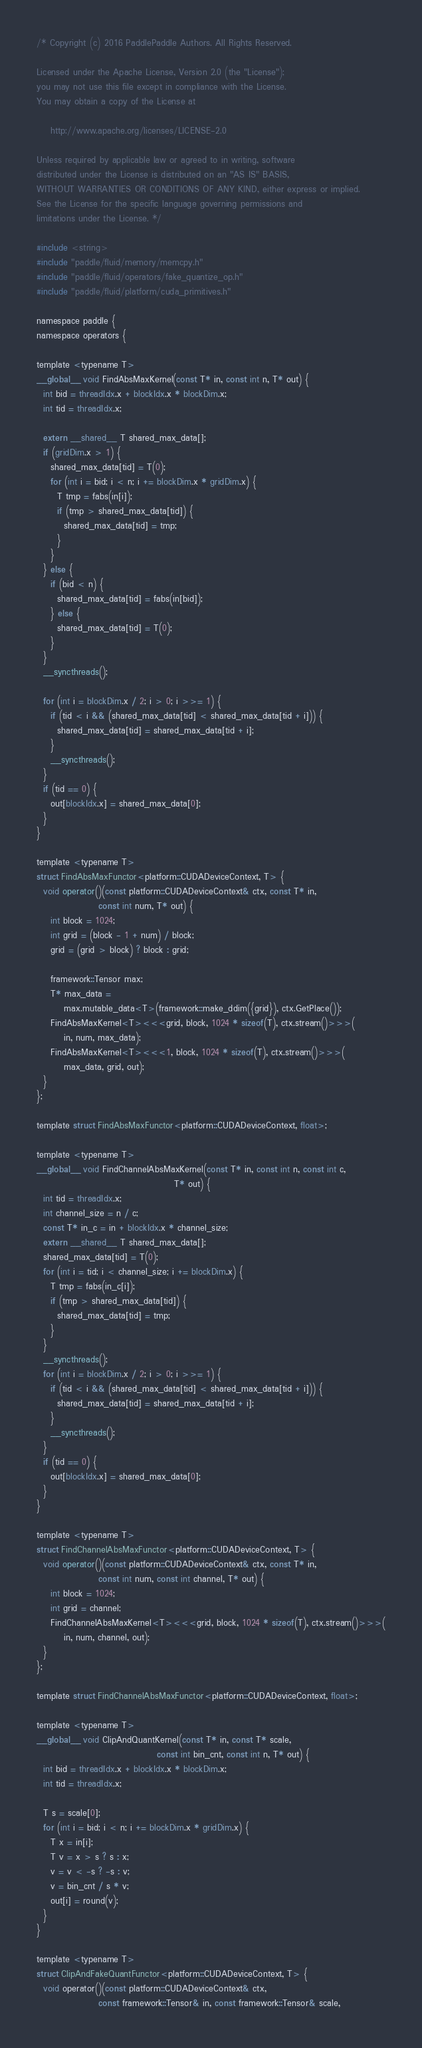<code> <loc_0><loc_0><loc_500><loc_500><_Cuda_>/* Copyright (c) 2016 PaddlePaddle Authors. All Rights Reserved.

Licensed under the Apache License, Version 2.0 (the "License");
you may not use this file except in compliance with the License.
You may obtain a copy of the License at

    http://www.apache.org/licenses/LICENSE-2.0

Unless required by applicable law or agreed to in writing, software
distributed under the License is distributed on an "AS IS" BASIS,
WITHOUT WARRANTIES OR CONDITIONS OF ANY KIND, either express or implied.
See the License for the specific language governing permissions and
limitations under the License. */

#include <string>
#include "paddle/fluid/memory/memcpy.h"
#include "paddle/fluid/operators/fake_quantize_op.h"
#include "paddle/fluid/platform/cuda_primitives.h"

namespace paddle {
namespace operators {

template <typename T>
__global__ void FindAbsMaxKernel(const T* in, const int n, T* out) {
  int bid = threadIdx.x + blockIdx.x * blockDim.x;
  int tid = threadIdx.x;

  extern __shared__ T shared_max_data[];
  if (gridDim.x > 1) {
    shared_max_data[tid] = T(0);
    for (int i = bid; i < n; i += blockDim.x * gridDim.x) {
      T tmp = fabs(in[i]);
      if (tmp > shared_max_data[tid]) {
        shared_max_data[tid] = tmp;
      }
    }
  } else {
    if (bid < n) {
      shared_max_data[tid] = fabs(in[bid]);
    } else {
      shared_max_data[tid] = T(0);
    }
  }
  __syncthreads();

  for (int i = blockDim.x / 2; i > 0; i >>= 1) {
    if (tid < i && (shared_max_data[tid] < shared_max_data[tid + i])) {
      shared_max_data[tid] = shared_max_data[tid + i];
    }
    __syncthreads();
  }
  if (tid == 0) {
    out[blockIdx.x] = shared_max_data[0];
  }
}

template <typename T>
struct FindAbsMaxFunctor<platform::CUDADeviceContext, T> {
  void operator()(const platform::CUDADeviceContext& ctx, const T* in,
                  const int num, T* out) {
    int block = 1024;
    int grid = (block - 1 + num) / block;
    grid = (grid > block) ? block : grid;

    framework::Tensor max;
    T* max_data =
        max.mutable_data<T>(framework::make_ddim({grid}), ctx.GetPlace());
    FindAbsMaxKernel<T><<<grid, block, 1024 * sizeof(T), ctx.stream()>>>(
        in, num, max_data);
    FindAbsMaxKernel<T><<<1, block, 1024 * sizeof(T), ctx.stream()>>>(
        max_data, grid, out);
  }
};

template struct FindAbsMaxFunctor<platform::CUDADeviceContext, float>;

template <typename T>
__global__ void FindChannelAbsMaxKernel(const T* in, const int n, const int c,
                                        T* out) {
  int tid = threadIdx.x;
  int channel_size = n / c;
  const T* in_c = in + blockIdx.x * channel_size;
  extern __shared__ T shared_max_data[];
  shared_max_data[tid] = T(0);
  for (int i = tid; i < channel_size; i += blockDim.x) {
    T tmp = fabs(in_c[i]);
    if (tmp > shared_max_data[tid]) {
      shared_max_data[tid] = tmp;
    }
  }
  __syncthreads();
  for (int i = blockDim.x / 2; i > 0; i >>= 1) {
    if (tid < i && (shared_max_data[tid] < shared_max_data[tid + i])) {
      shared_max_data[tid] = shared_max_data[tid + i];
    }
    __syncthreads();
  }
  if (tid == 0) {
    out[blockIdx.x] = shared_max_data[0];
  }
}

template <typename T>
struct FindChannelAbsMaxFunctor<platform::CUDADeviceContext, T> {
  void operator()(const platform::CUDADeviceContext& ctx, const T* in,
                  const int num, const int channel, T* out) {
    int block = 1024;
    int grid = channel;
    FindChannelAbsMaxKernel<T><<<grid, block, 1024 * sizeof(T), ctx.stream()>>>(
        in, num, channel, out);
  }
};

template struct FindChannelAbsMaxFunctor<platform::CUDADeviceContext, float>;

template <typename T>
__global__ void ClipAndQuantKernel(const T* in, const T* scale,
                                   const int bin_cnt, const int n, T* out) {
  int bid = threadIdx.x + blockIdx.x * blockDim.x;
  int tid = threadIdx.x;

  T s = scale[0];
  for (int i = bid; i < n; i += blockDim.x * gridDim.x) {
    T x = in[i];
    T v = x > s ? s : x;
    v = v < -s ? -s : v;
    v = bin_cnt / s * v;
    out[i] = round(v);
  }
}

template <typename T>
struct ClipAndFakeQuantFunctor<platform::CUDADeviceContext, T> {
  void operator()(const platform::CUDADeviceContext& ctx,
                  const framework::Tensor& in, const framework::Tensor& scale,</code> 